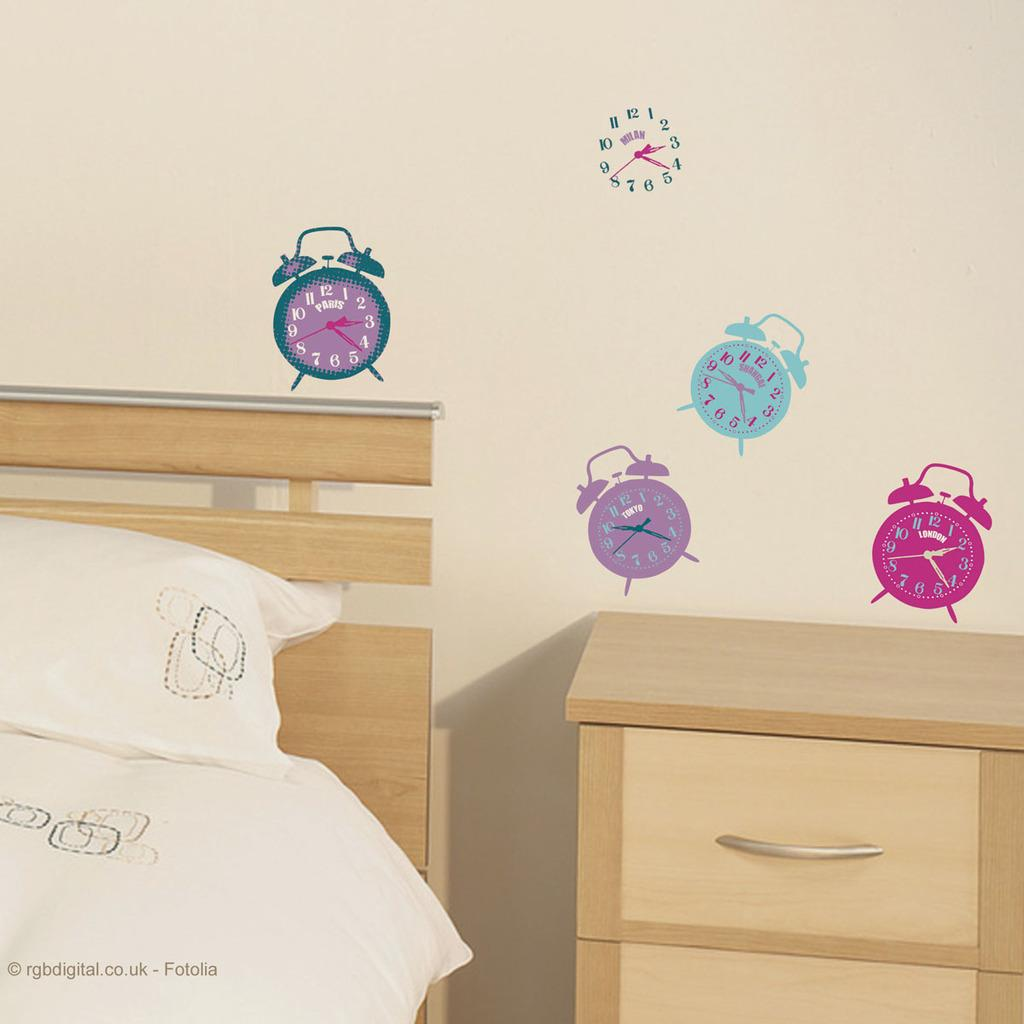Provide a one-sentence caption for the provided image. The clock pictures on the wall all read different times. 